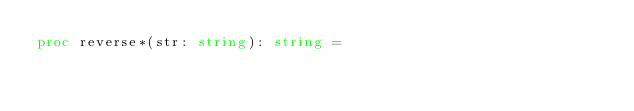Convert code to text. <code><loc_0><loc_0><loc_500><loc_500><_Nim_>proc reverse*(str: string): string =</code> 